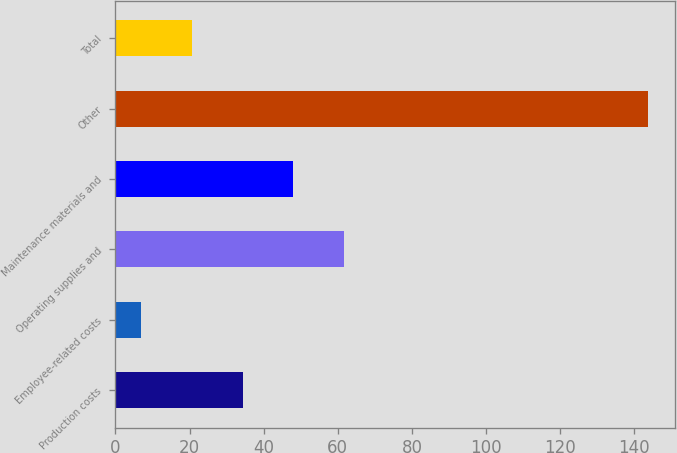Convert chart to OTSL. <chart><loc_0><loc_0><loc_500><loc_500><bar_chart><fcel>Production costs<fcel>Employee-related costs<fcel>Operating supplies and<fcel>Maintenance materials and<fcel>Other<fcel>Total<nl><fcel>34.28<fcel>6.9<fcel>61.66<fcel>47.97<fcel>143.8<fcel>20.59<nl></chart> 